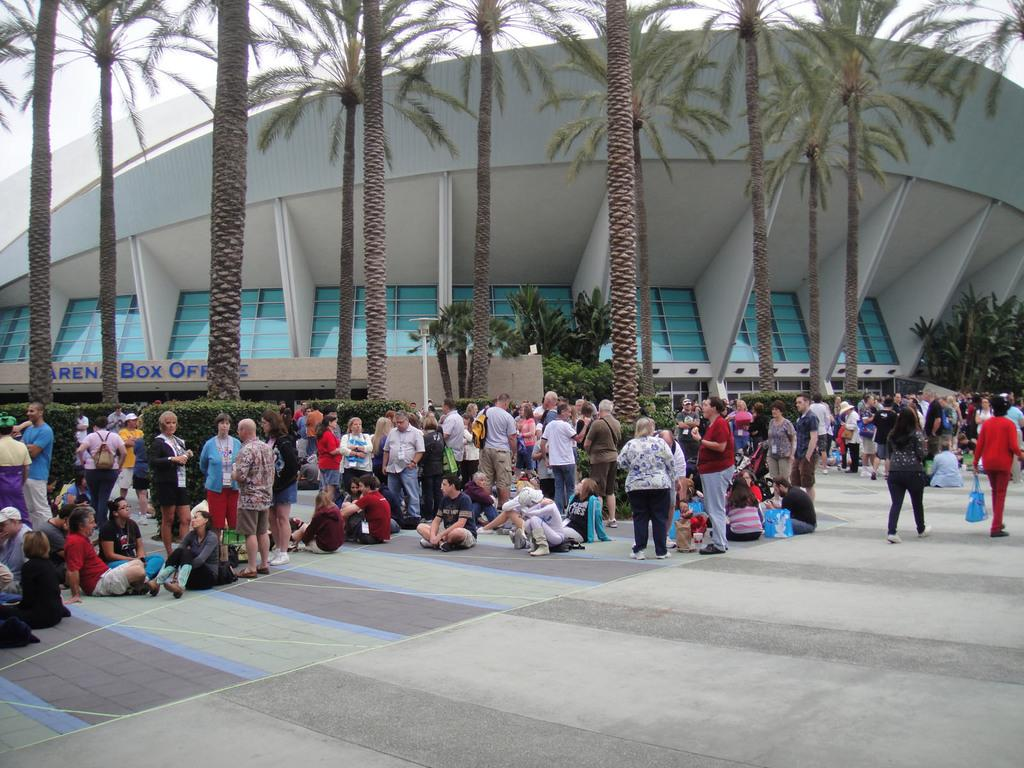How many people are in the image? There is a group of people in the image, but the exact number cannot be determined from the provided facts. What are the people in the image doing? Some people are sitting on the ground, and some are standing. What objects can be seen in the image besides people? There are bags, trees, and a building visible in the image. What is visible in the background of the image? The sky is visible in the background of the image. Can you see any ghosts interacting with the people in the image? There are no ghosts present in the image; it only features a group of people, bags, trees, a building, and the sky. 